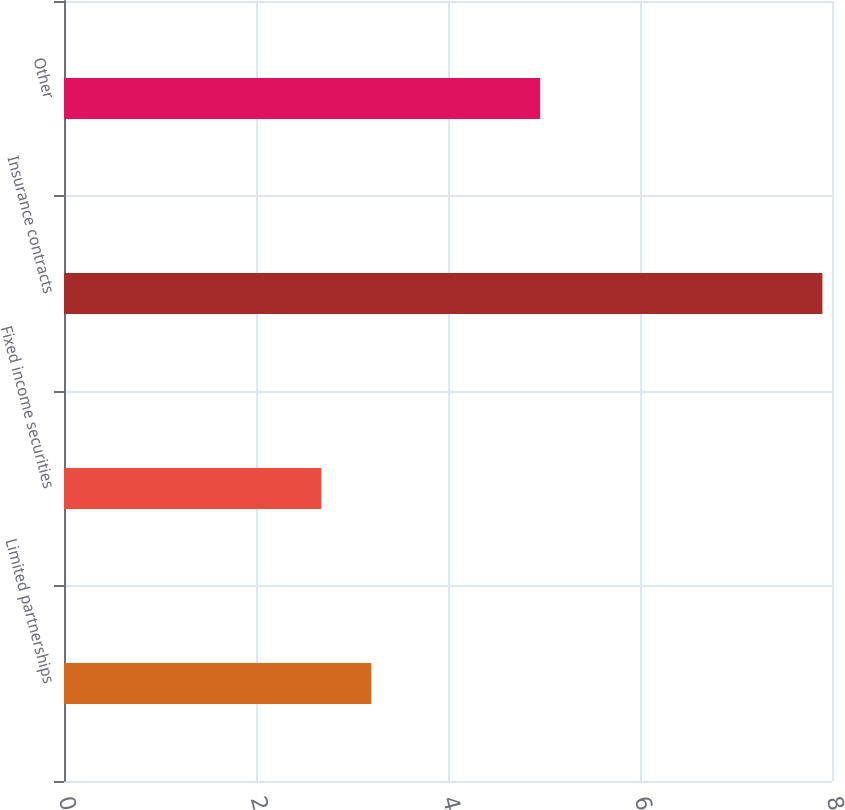Convert chart. <chart><loc_0><loc_0><loc_500><loc_500><bar_chart><fcel>Limited partnerships<fcel>Fixed income securities<fcel>Insurance contracts<fcel>Other<nl><fcel>3.2<fcel>2.68<fcel>7.9<fcel>4.96<nl></chart> 